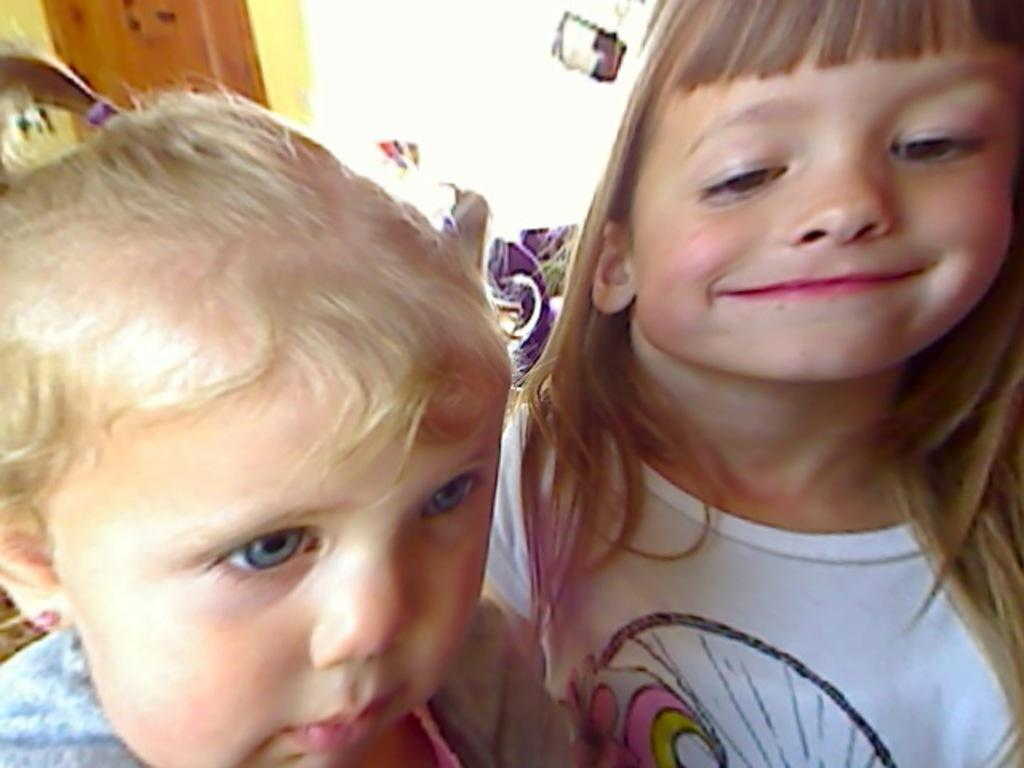How many girls are in the image? There are two girls in the image. What expression do the girls have? The girls are smiling. Can you describe the background details be seen clearly in the image? No, the background of the image is blurry. What type of cave can be seen in the background of the image? There is no cave present in the image; the background is blurry and does not show any specific location or structure. --- Facts: 1. There is a person holding a camera in the image. 2. The person is taking a picture of a building. 3. The building is in the background of the image. 4. The sky is visible in the background of the image. Absurd Topics: dance, rainbow, bird Conversation: What is the person in the image holding? The person in the image is holding a camera. What is the person doing with the camera? The person is taking a picture of a building. Where is the building located in the image? The building is in the background of the image. What else can be seen in the background of the image? The sky is visible in the background of the image. Reasoning: Let's think step by step in order to produce the conversation. We start by identifying the main subject in the image, which is the person holding a camera. Then, we describe what the person is doing with the camera and the location of the building in the background. Finally, we mention the sky visible in the background. Each question is designed to elicit a specific detail about the image that is known from the provided facts. Absurd Question/Answer: Can you see a bird flying in the sky in the image? There is no bird visible in the image; the focus is on the person holding the camera and the building in the background. --- Facts: 1. There is a cat sitting on a chair in the image. 2. There is a table with some books on it in the image. 3. The cat is looking at the books. 4. The table is in front of the chair. Absurd Topics: fish, ocean, boat Conversation: What is the main subject in the image? The main subject in the image is a cat sitting on a chair. What is the cat doing in the image? The cat is looking at the books on the table. Where is the table located in relation to the chair? The table is in front of the chair. What else can be seen on the table besides the books? The provided facts do not mention anything else on the table besides the books. Reasoning: Let's think step by step in order to produce the conversation. We start by identifying the main subject in the image, which is the cat sitting on a chair. Then, we describe what the cat is doing and the location of the table in relation to the chair. Finally, we mention that the table has books on it, 